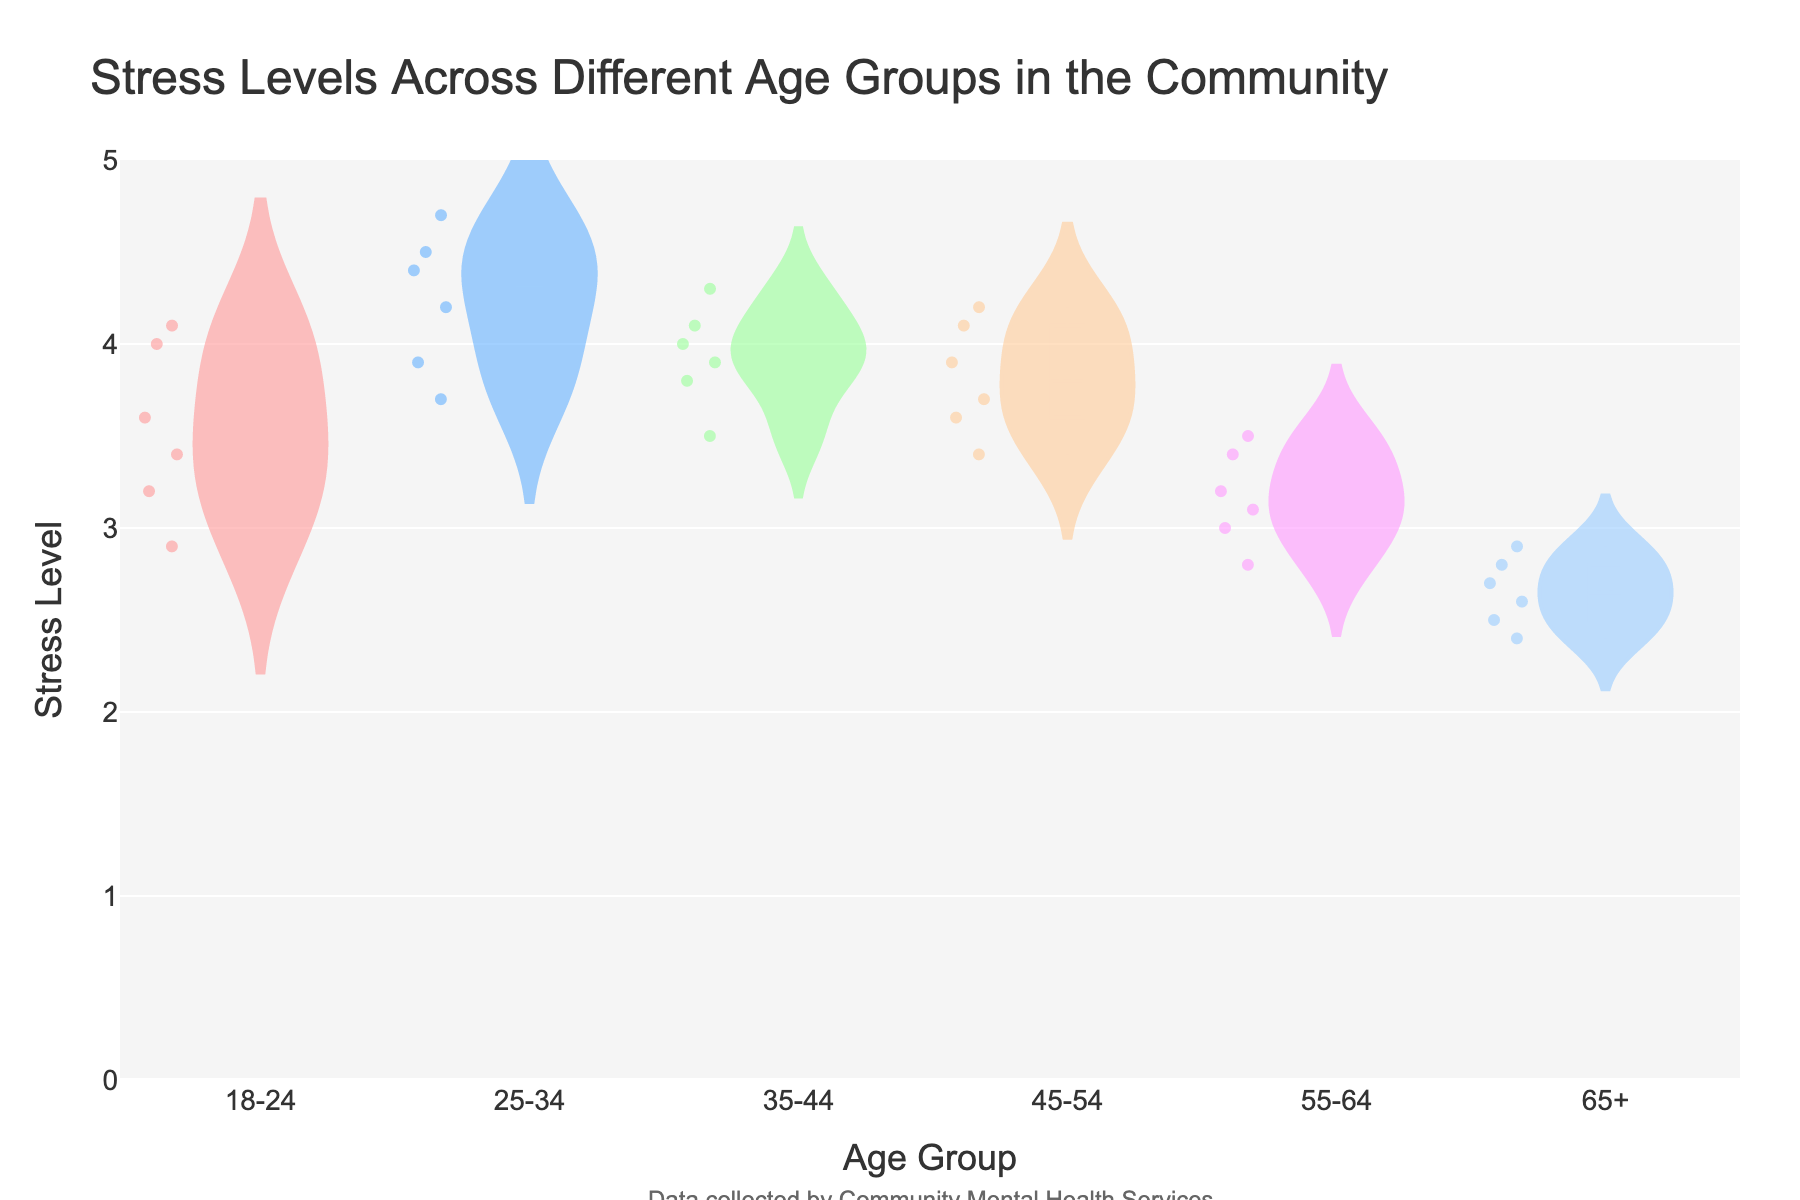What's the title of the figure? The title is located at the top of the figure. It is usually written in a larger font and provides a summary of what the graph is about.
Answer: Stress Levels Across Different Age Groups in the Community What age group has the highest mean stress level? The figure shows mean lines for each age group. By comparing these lines, you can determine which group has the highest mean stress level.
Answer: 25-34 How do the stress levels of the age group 65+ compare to other age groups? You'll need to look at the density and distribution of stress levels for age group 65+ and compare it with other groups. The 65+ group visibly has lower stress levels overall.
Answer: Lower Which age group has the widest range of stress levels? Examine the spread of data points and the length of the violin plot for each age group to see which one covers the most extensive range of stress levels.
Answer: 25-34 What is the stress level range for the age group 45-54? Look at the lowest and highest points on the violin plot for the age group 45-54 to determine the range. The range is given by the minimum and maximum stress levels.
Answer: 3.4 to 4.2 Are there any age groups that show data points outside the inner quartile range? If so, which ones? Check for data points that fall outside the box (which represents the inner quartile range) within each violin plot.
Answer: Yes, all age groups What is the color used for the age group 55-64 and what does it represent? Locate the violin plot for age group 55-64 and note its color. The color represents the stress levels for that age group.
Answer: Pinkish-purple Based on the figure, which age group has the most similar stress levels and how can you tell? Look for the age group with the properties of consistent stress levels by examining the tightness and concentration of data points. The closer they are, the more similar the stress levels.
Answer: 65+ How does the average stress level of the age group 35-44 compare to the age group 55-64? Check the mean line within the violin plots for both age groups, then compare their heights to determine which has a higher mean stress level.
Answer: Higher for 35-44 What additional information is provided about the data source? There is often a small annotation or text outside the main area of the plot that provides details about the data source or the collection method.
Answer: Data collected by Community Mental Health Services 